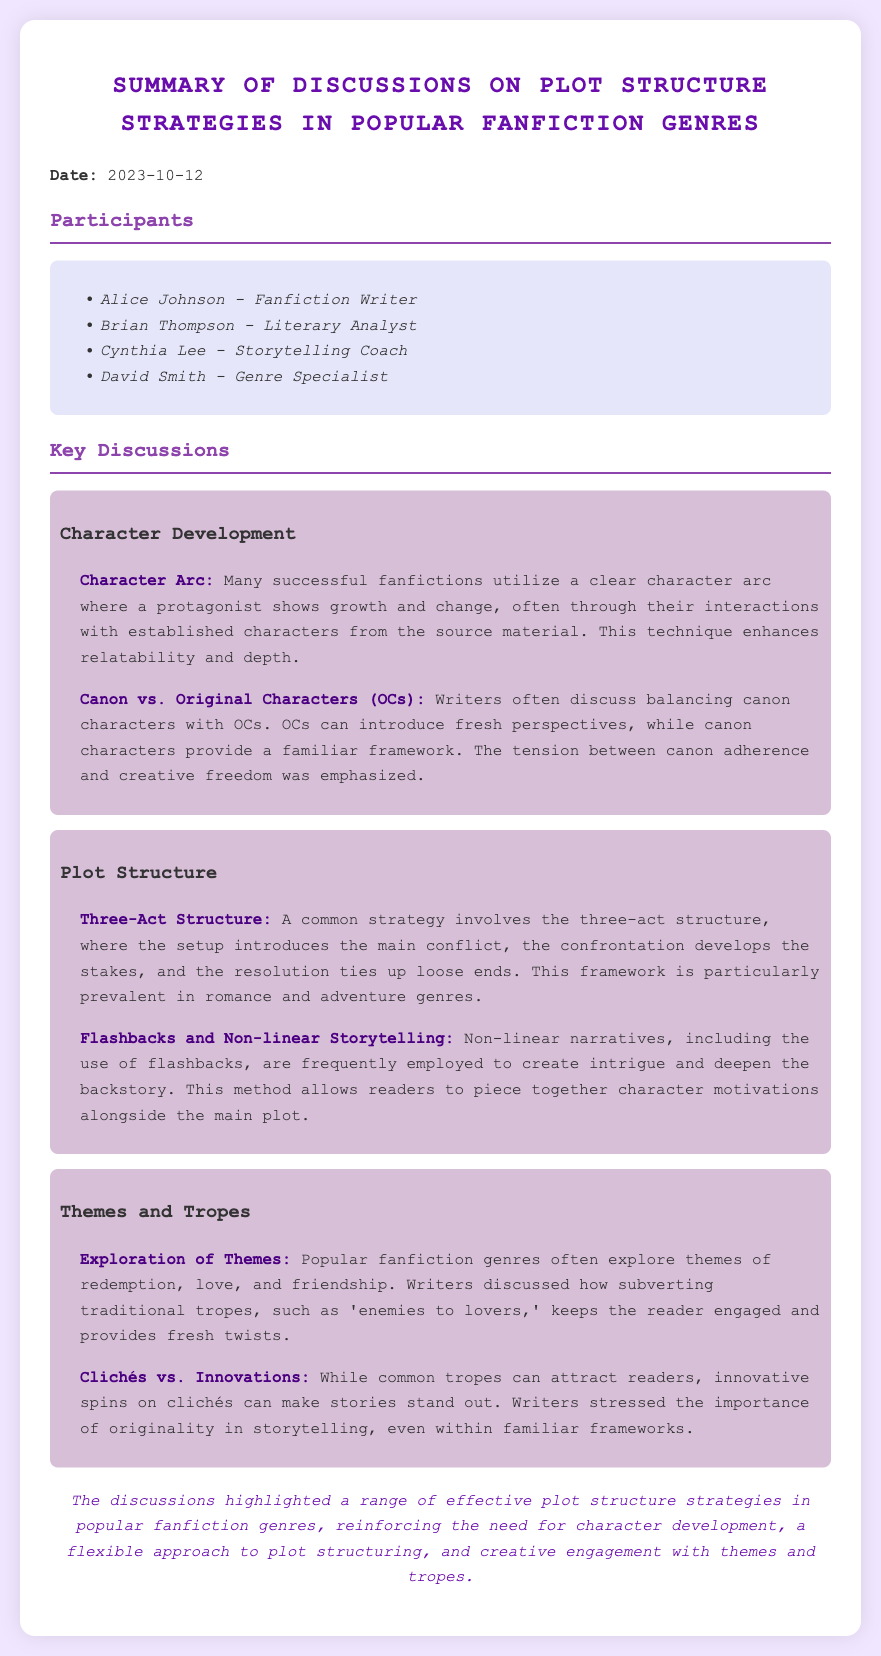What is the date of the meeting? The date of the meeting is explicitly stated in the document as 2023-10-12.
Answer: 2023-10-12 Who is the genre specialist participant? The document lists David Smith as the genre specialist among the participants.
Answer: David Smith What character development technique emphasizes growth through interactions? The document mentions "Character Arc" as a technique that highlights character growth through interactions.
Answer: Character Arc What plot structure strategy is mentioned as common in romance and adventure genres? The text indicates that the "Three-Act Structure" is a prevalent strategy in these genres.
Answer: Three-Act Structure Which theme is frequently explored in popular fanfiction genres? The document states that themes like "redemption" are often explored in popular fanfiction.
Answer: redemption What does the document suggest about OCs in relation to canon characters? The document discusses the balance between "canon characters and OCs" in fanfiction writing.
Answer: canon characters and OCs Which storytelling technique involves presenting events in a non-linear fashion? The document refers to "Flashbacks and Non-linear Storytelling" as the technique that involves this approach.
Answer: Flashbacks and Non-linear Storytelling What is highlighted as essential for effective storytelling in fanfiction? The conclusion emphasizes the need for "character development" as a crucial element in storytelling.
Answer: character development 